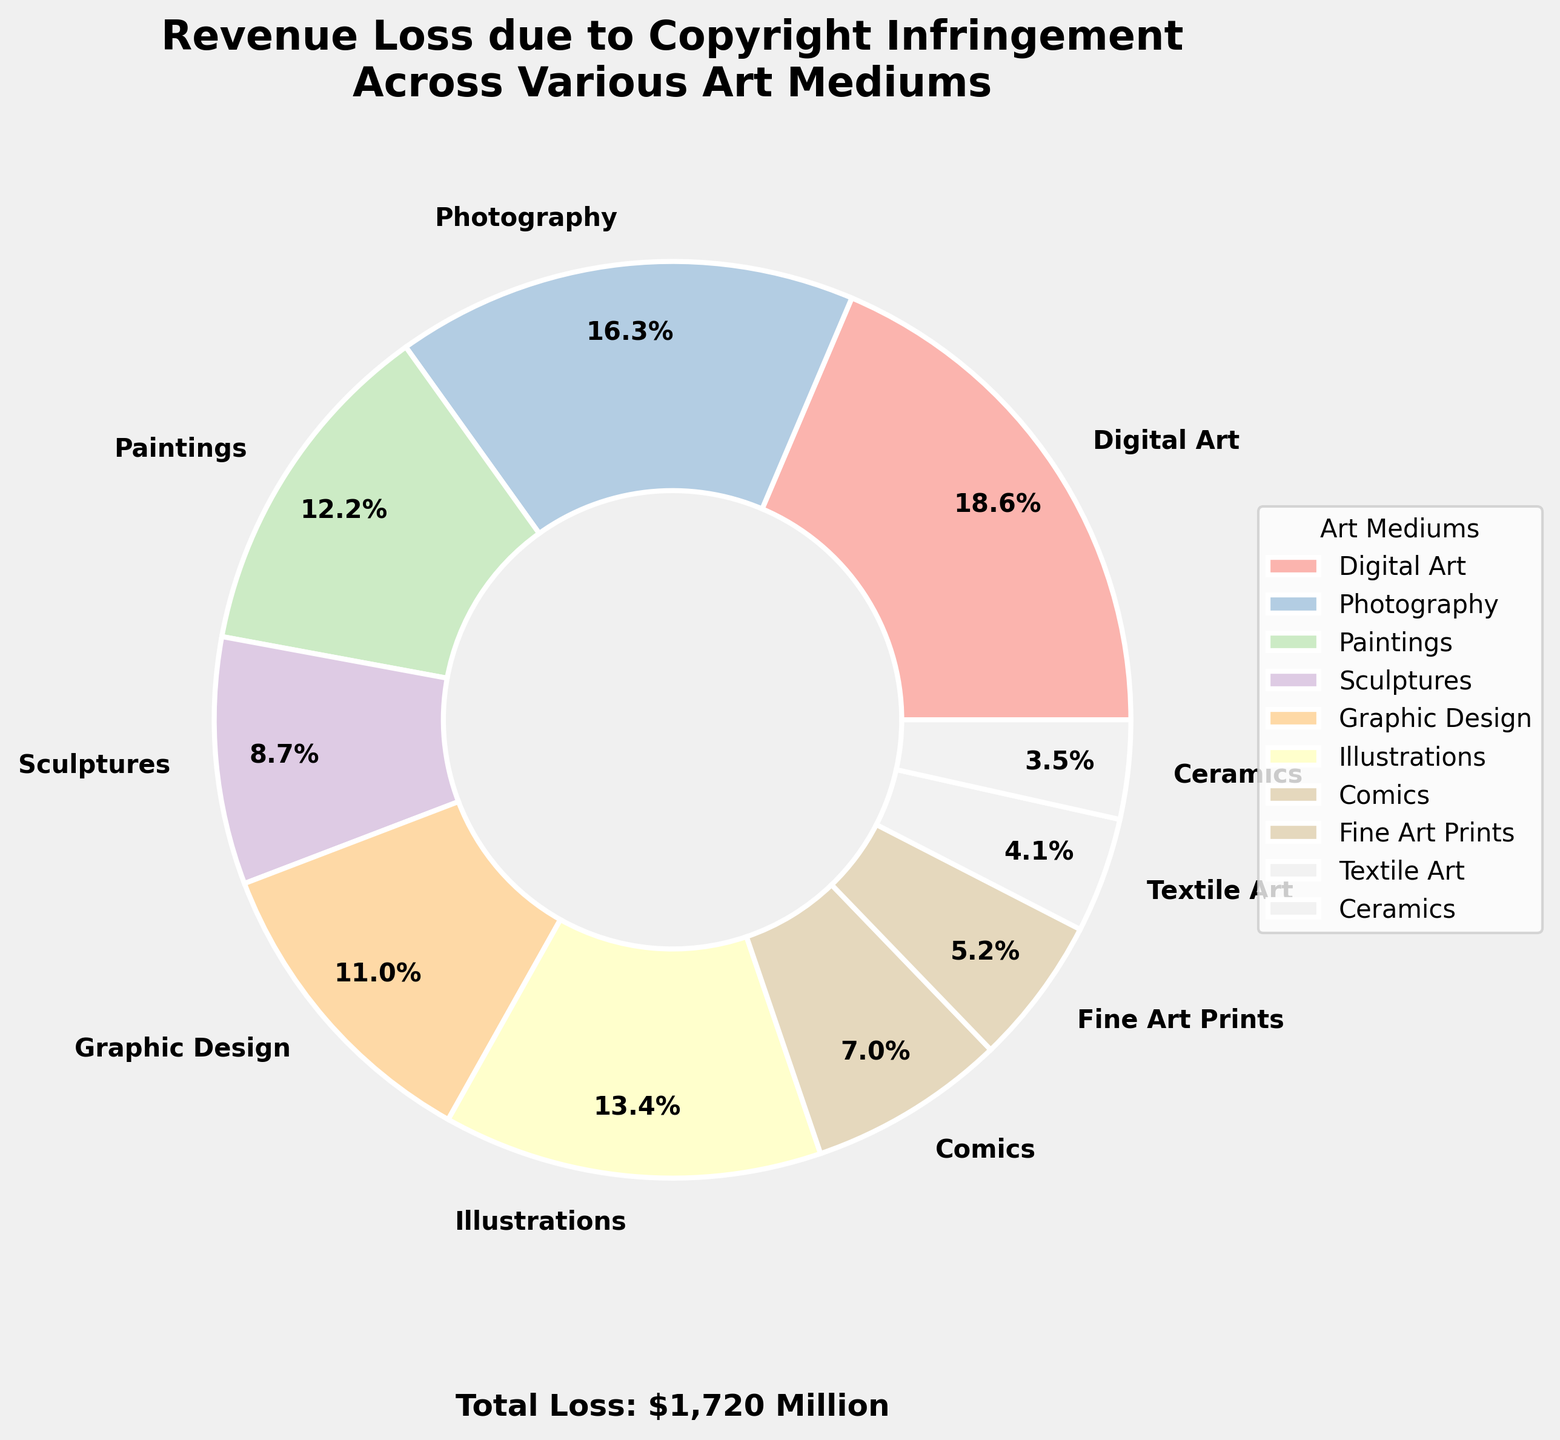Which art medium contributes the most to revenue loss due to copyright infringement? The pie chart labels and percentages indicate that "Digital Art" has the highest proportion of revenue loss.
Answer: Digital Art What is the combined revenue loss for Paintings and Sculptures? The pie chart shows "Paintings" have a revenue loss of $210 million and "Sculptures" have a revenue loss of $150 million. Adding these: 210 + 150 = 360.
Answer: $360 Million How does the revenue loss for Comics compare to Graphic Design? The chart indicates "Comics" have a loss of $120 million and "Graphic Design" has a loss of $190 million. Since 190 > 120, Graphic Design's loss is greater.
Answer: Graphic Design has a greater loss What is the total revenue loss of the three least affected art mediums? The chart reveals the three least affected mediums: "Textile Art" ($70 million), "Ceramics" ($60 million), and "Fine Art Prints" ($90 million). Adding these: 70 + 60 + 90 = 220.
Answer: $220 Million Which two art mediums have the closest revenue loss values? By observing the percentages and values, "Graphic Design" ($190 million) and "Illustrations" ($230 million) are the closest in loss values. The difference is 230 - 190 = 40.
Answer: Graphic Design and Illustrations What is the average revenue loss among all art mediums? Summing all the losses: 320 + 280 + 210 + 150 + 190 + 230 + 120 + 90 + 70 + 60 = 1720. There are 10 art mediums. The average loss is 1720 / 10 = 172.
Answer: $172 Million Which art mediums contribute to more than 20% of the total revenue loss? The pie chart visually shows that only "Digital Art" (18.6%) and "Photography" (16.3%) contribute more than 20% individually out of any possible combinations.
Answer: None individually How does the color scheme help in distinguishing various art mediums? The pie chart uses a pastel color palette with unique colors for each section, making it easier to distinguish between different art mediums.
Answer: Unique pastel colors What is the median revenue loss among all art mediums? Sorting the losses: 60, 70, 90, 120, 150, 190, 210, 230, 280, 320. With 10 data points, the median is the average of the 5th and 6th values: (150 + 190) / 2 = 170.
Answer: $170 Million 